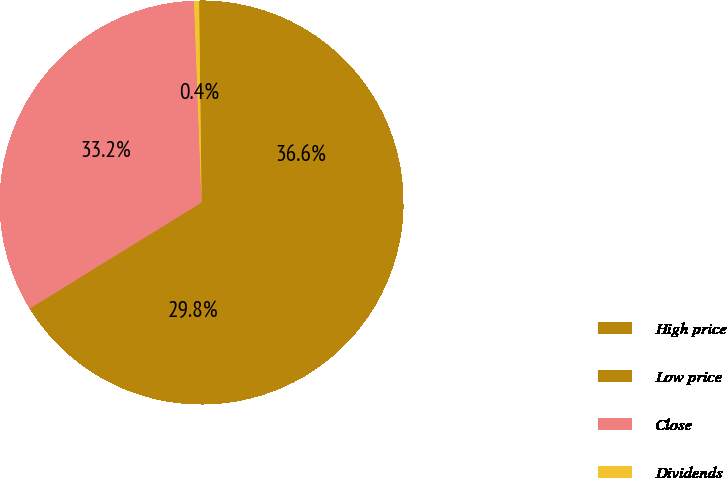Convert chart. <chart><loc_0><loc_0><loc_500><loc_500><pie_chart><fcel>High price<fcel>Low price<fcel>Close<fcel>Dividends<nl><fcel>36.56%<fcel>29.85%<fcel>33.2%<fcel>0.4%<nl></chart> 